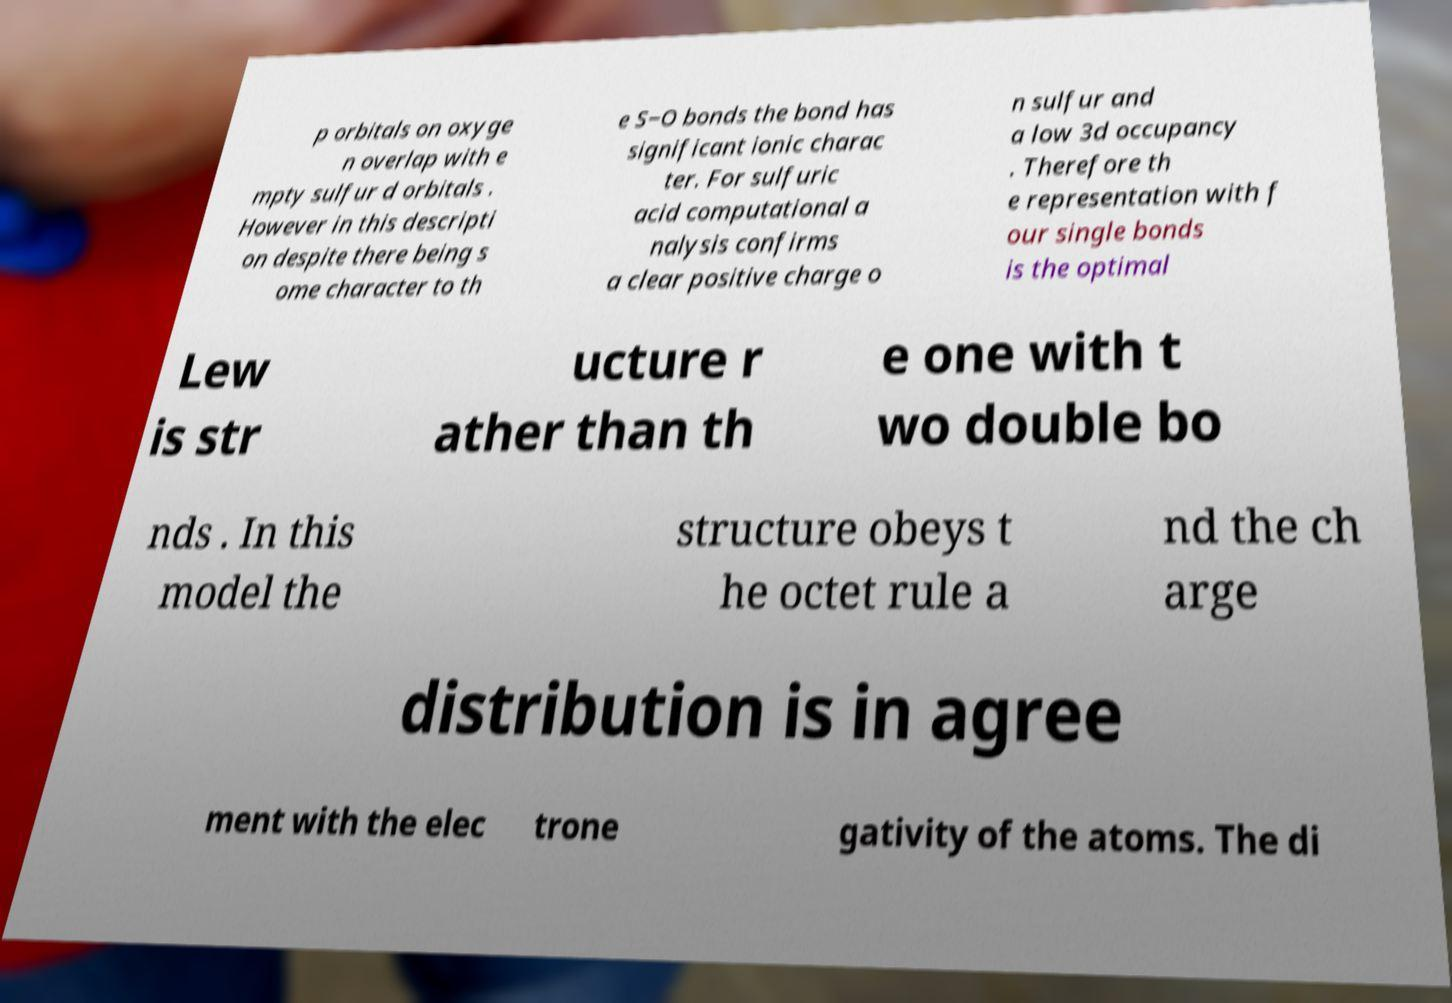What messages or text are displayed in this image? I need them in a readable, typed format. p orbitals on oxyge n overlap with e mpty sulfur d orbitals . However in this descripti on despite there being s ome character to th e S−O bonds the bond has significant ionic charac ter. For sulfuric acid computational a nalysis confirms a clear positive charge o n sulfur and a low 3d occupancy . Therefore th e representation with f our single bonds is the optimal Lew is str ucture r ather than th e one with t wo double bo nds . In this model the structure obeys t he octet rule a nd the ch arge distribution is in agree ment with the elec trone gativity of the atoms. The di 